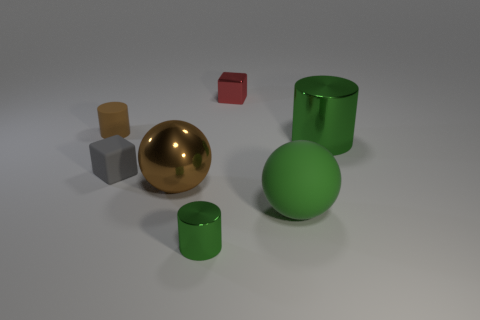Subtract all shiny cylinders. How many cylinders are left? 1 Add 3 green matte spheres. How many objects exist? 10 Subtract all blocks. Subtract all small green objects. How many objects are left? 4 Add 2 large brown shiny things. How many large brown shiny things are left? 3 Add 6 tiny metal balls. How many tiny metal balls exist? 6 Subtract all red cubes. How many cubes are left? 1 Subtract 0 yellow blocks. How many objects are left? 7 Subtract all blocks. How many objects are left? 5 Subtract 1 blocks. How many blocks are left? 1 Subtract all brown cylinders. Subtract all gray cubes. How many cylinders are left? 2 